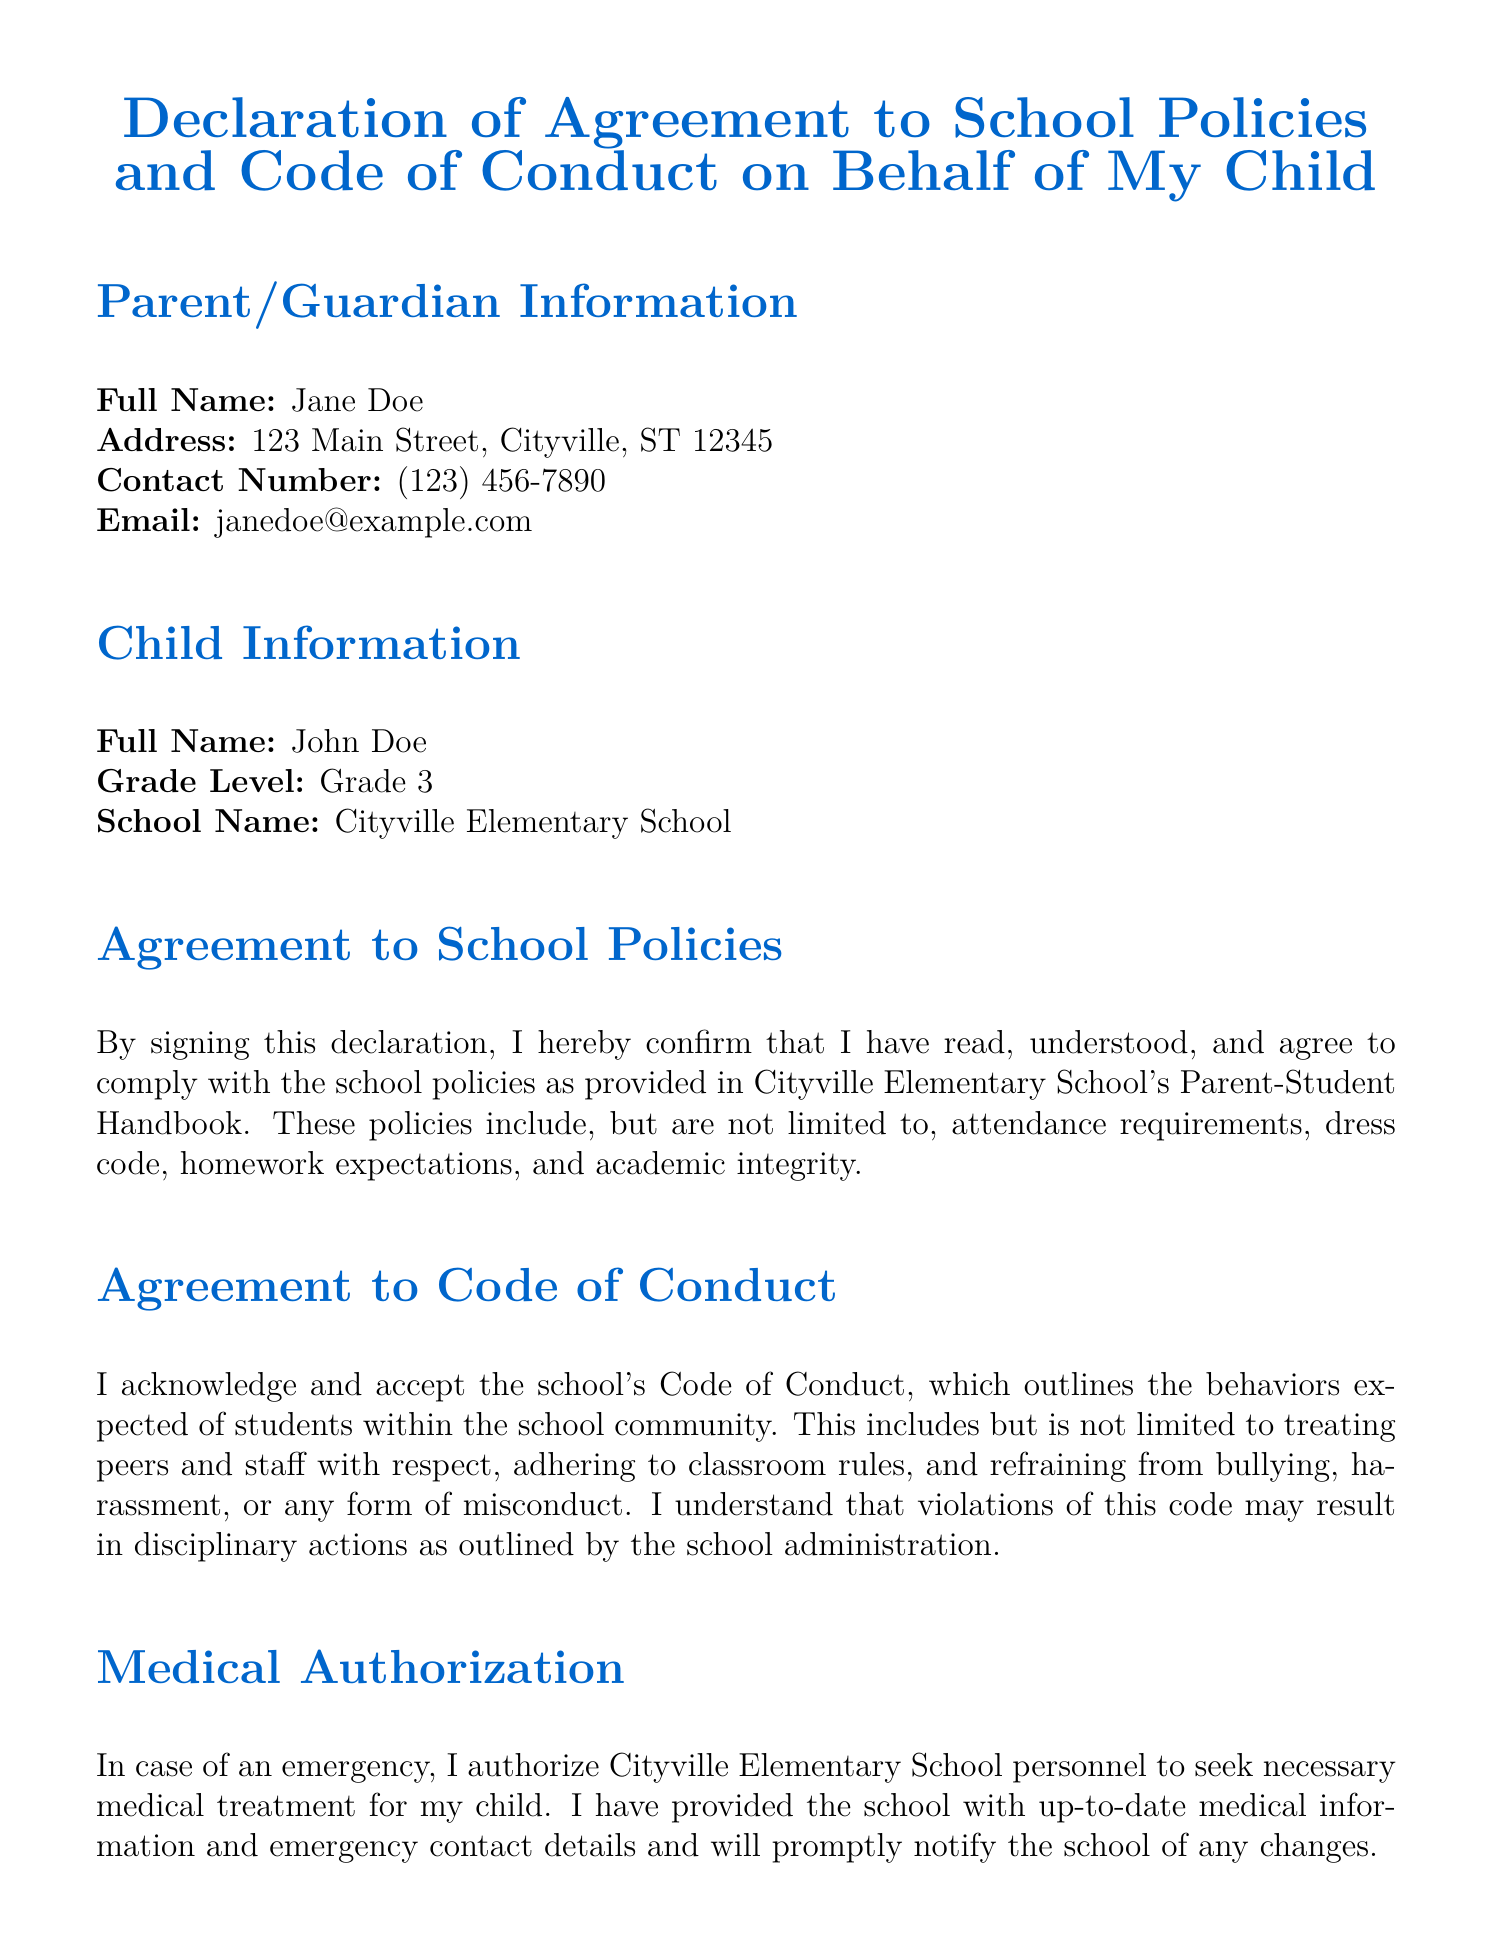What is the parent's full name? The parent's full name is listed in the document under Parent/Guardian Information.
Answer: Jane Doe What grade is the child in? The child's grade level is specified in the Child Information section of the document.
Answer: Grade 3 What is the school name? The school name is mentioned alongside the child's information in the document.
Answer: Cityville Elementary School What date is the signature dated? The date of the signature is presented at the end of the document.
Answer: October 15, 2023 What is one of the school policies mentioned? The document lists attendance requirements, dress code, homework expectations, and academic integrity as part of school policies.
Answer: Attendance requirements What must a parent do regarding medical information? The document states that the parent must provide up-to-date medical information and emergency contact details.
Answer: Provide up-to-date medical information What does the Code of Conduct address? The Code of Conduct addresses expected behaviors of students including respect for peers and staff.
Answer: Expected behaviors of students What can happen if the Code of Conduct is violated? The document states that violations of the Code of Conduct may result in disciplinary actions.
Answer: Disciplinary actions What is required for field trip participation? The document specifies that permission must be given for the child to attend school-organized field trips.
Answer: Permission must be given 